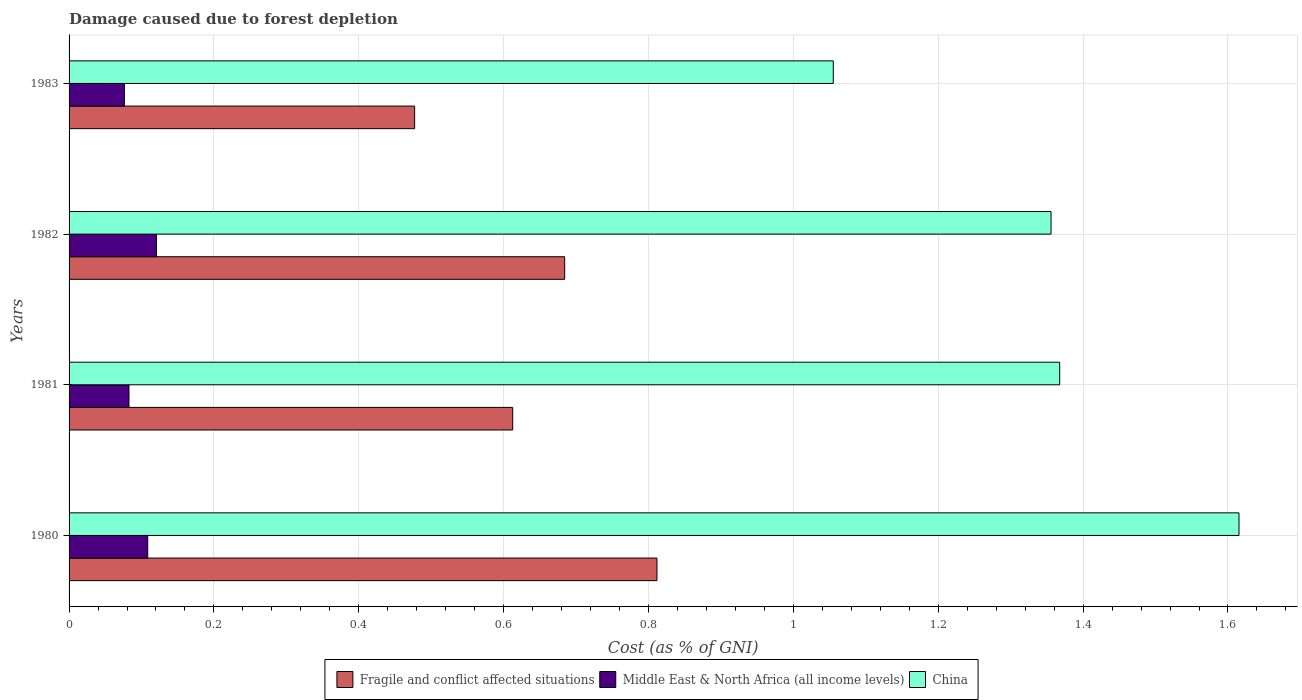How many different coloured bars are there?
Your answer should be very brief. 3. Are the number of bars per tick equal to the number of legend labels?
Offer a terse response. Yes. Are the number of bars on each tick of the Y-axis equal?
Your answer should be very brief. Yes. How many bars are there on the 1st tick from the bottom?
Your answer should be very brief. 3. What is the label of the 2nd group of bars from the top?
Keep it short and to the point. 1982. In how many cases, is the number of bars for a given year not equal to the number of legend labels?
Offer a terse response. 0. What is the cost of damage caused due to forest depletion in China in 1981?
Make the answer very short. 1.37. Across all years, what is the maximum cost of damage caused due to forest depletion in China?
Your answer should be very brief. 1.62. Across all years, what is the minimum cost of damage caused due to forest depletion in Fragile and conflict affected situations?
Make the answer very short. 0.48. What is the total cost of damage caused due to forest depletion in Fragile and conflict affected situations in the graph?
Ensure brevity in your answer.  2.59. What is the difference between the cost of damage caused due to forest depletion in China in 1981 and that in 1983?
Make the answer very short. 0.31. What is the difference between the cost of damage caused due to forest depletion in Fragile and conflict affected situations in 1983 and the cost of damage caused due to forest depletion in China in 1982?
Keep it short and to the point. -0.88. What is the average cost of damage caused due to forest depletion in Middle East & North Africa (all income levels) per year?
Offer a very short reply. 0.1. In the year 1981, what is the difference between the cost of damage caused due to forest depletion in Middle East & North Africa (all income levels) and cost of damage caused due to forest depletion in China?
Your response must be concise. -1.28. What is the ratio of the cost of damage caused due to forest depletion in Fragile and conflict affected situations in 1980 to that in 1981?
Keep it short and to the point. 1.33. What is the difference between the highest and the second highest cost of damage caused due to forest depletion in Fragile and conflict affected situations?
Ensure brevity in your answer.  0.13. What is the difference between the highest and the lowest cost of damage caused due to forest depletion in Middle East & North Africa (all income levels)?
Provide a succinct answer. 0.04. Is the sum of the cost of damage caused due to forest depletion in Fragile and conflict affected situations in 1980 and 1982 greater than the maximum cost of damage caused due to forest depletion in Middle East & North Africa (all income levels) across all years?
Your answer should be very brief. Yes. What does the 3rd bar from the top in 1983 represents?
Your answer should be compact. Fragile and conflict affected situations. What does the 1st bar from the bottom in 1980 represents?
Offer a terse response. Fragile and conflict affected situations. Is it the case that in every year, the sum of the cost of damage caused due to forest depletion in Fragile and conflict affected situations and cost of damage caused due to forest depletion in China is greater than the cost of damage caused due to forest depletion in Middle East & North Africa (all income levels)?
Offer a terse response. Yes. How many bars are there?
Provide a succinct answer. 12. Are all the bars in the graph horizontal?
Your response must be concise. Yes. How many years are there in the graph?
Make the answer very short. 4. What is the difference between two consecutive major ticks on the X-axis?
Provide a short and direct response. 0.2. Are the values on the major ticks of X-axis written in scientific E-notation?
Ensure brevity in your answer.  No. Where does the legend appear in the graph?
Make the answer very short. Bottom center. How many legend labels are there?
Make the answer very short. 3. How are the legend labels stacked?
Offer a terse response. Horizontal. What is the title of the graph?
Provide a succinct answer. Damage caused due to forest depletion. Does "Libya" appear as one of the legend labels in the graph?
Offer a very short reply. No. What is the label or title of the X-axis?
Offer a very short reply. Cost (as % of GNI). What is the label or title of the Y-axis?
Give a very brief answer. Years. What is the Cost (as % of GNI) in Fragile and conflict affected situations in 1980?
Your answer should be compact. 0.81. What is the Cost (as % of GNI) in Middle East & North Africa (all income levels) in 1980?
Your response must be concise. 0.11. What is the Cost (as % of GNI) of China in 1980?
Ensure brevity in your answer.  1.62. What is the Cost (as % of GNI) in Fragile and conflict affected situations in 1981?
Your response must be concise. 0.61. What is the Cost (as % of GNI) in Middle East & North Africa (all income levels) in 1981?
Offer a terse response. 0.08. What is the Cost (as % of GNI) of China in 1981?
Your response must be concise. 1.37. What is the Cost (as % of GNI) in Fragile and conflict affected situations in 1982?
Offer a terse response. 0.68. What is the Cost (as % of GNI) in Middle East & North Africa (all income levels) in 1982?
Provide a succinct answer. 0.12. What is the Cost (as % of GNI) in China in 1982?
Keep it short and to the point. 1.36. What is the Cost (as % of GNI) in Fragile and conflict affected situations in 1983?
Your answer should be compact. 0.48. What is the Cost (as % of GNI) of Middle East & North Africa (all income levels) in 1983?
Ensure brevity in your answer.  0.08. What is the Cost (as % of GNI) of China in 1983?
Give a very brief answer. 1.06. Across all years, what is the maximum Cost (as % of GNI) in Fragile and conflict affected situations?
Ensure brevity in your answer.  0.81. Across all years, what is the maximum Cost (as % of GNI) in Middle East & North Africa (all income levels)?
Give a very brief answer. 0.12. Across all years, what is the maximum Cost (as % of GNI) in China?
Your answer should be very brief. 1.62. Across all years, what is the minimum Cost (as % of GNI) in Fragile and conflict affected situations?
Ensure brevity in your answer.  0.48. Across all years, what is the minimum Cost (as % of GNI) in Middle East & North Africa (all income levels)?
Provide a succinct answer. 0.08. Across all years, what is the minimum Cost (as % of GNI) of China?
Make the answer very short. 1.06. What is the total Cost (as % of GNI) in Fragile and conflict affected situations in the graph?
Provide a succinct answer. 2.59. What is the total Cost (as % of GNI) in Middle East & North Africa (all income levels) in the graph?
Ensure brevity in your answer.  0.39. What is the total Cost (as % of GNI) of China in the graph?
Offer a terse response. 5.39. What is the difference between the Cost (as % of GNI) in Fragile and conflict affected situations in 1980 and that in 1981?
Offer a terse response. 0.2. What is the difference between the Cost (as % of GNI) in Middle East & North Africa (all income levels) in 1980 and that in 1981?
Offer a terse response. 0.03. What is the difference between the Cost (as % of GNI) of China in 1980 and that in 1981?
Offer a terse response. 0.25. What is the difference between the Cost (as % of GNI) in Fragile and conflict affected situations in 1980 and that in 1982?
Offer a very short reply. 0.13. What is the difference between the Cost (as % of GNI) in Middle East & North Africa (all income levels) in 1980 and that in 1982?
Make the answer very short. -0.01. What is the difference between the Cost (as % of GNI) of China in 1980 and that in 1982?
Offer a terse response. 0.26. What is the difference between the Cost (as % of GNI) in Fragile and conflict affected situations in 1980 and that in 1983?
Your response must be concise. 0.33. What is the difference between the Cost (as % of GNI) of Middle East & North Africa (all income levels) in 1980 and that in 1983?
Give a very brief answer. 0.03. What is the difference between the Cost (as % of GNI) of China in 1980 and that in 1983?
Ensure brevity in your answer.  0.56. What is the difference between the Cost (as % of GNI) of Fragile and conflict affected situations in 1981 and that in 1982?
Offer a terse response. -0.07. What is the difference between the Cost (as % of GNI) in Middle East & North Africa (all income levels) in 1981 and that in 1982?
Provide a succinct answer. -0.04. What is the difference between the Cost (as % of GNI) in China in 1981 and that in 1982?
Offer a very short reply. 0.01. What is the difference between the Cost (as % of GNI) of Fragile and conflict affected situations in 1981 and that in 1983?
Your answer should be very brief. 0.14. What is the difference between the Cost (as % of GNI) in Middle East & North Africa (all income levels) in 1981 and that in 1983?
Make the answer very short. 0.01. What is the difference between the Cost (as % of GNI) of China in 1981 and that in 1983?
Make the answer very short. 0.31. What is the difference between the Cost (as % of GNI) in Fragile and conflict affected situations in 1982 and that in 1983?
Keep it short and to the point. 0.21. What is the difference between the Cost (as % of GNI) of Middle East & North Africa (all income levels) in 1982 and that in 1983?
Your answer should be very brief. 0.04. What is the difference between the Cost (as % of GNI) of China in 1982 and that in 1983?
Give a very brief answer. 0.3. What is the difference between the Cost (as % of GNI) of Fragile and conflict affected situations in 1980 and the Cost (as % of GNI) of Middle East & North Africa (all income levels) in 1981?
Give a very brief answer. 0.73. What is the difference between the Cost (as % of GNI) of Fragile and conflict affected situations in 1980 and the Cost (as % of GNI) of China in 1981?
Offer a very short reply. -0.56. What is the difference between the Cost (as % of GNI) of Middle East & North Africa (all income levels) in 1980 and the Cost (as % of GNI) of China in 1981?
Offer a very short reply. -1.26. What is the difference between the Cost (as % of GNI) in Fragile and conflict affected situations in 1980 and the Cost (as % of GNI) in Middle East & North Africa (all income levels) in 1982?
Give a very brief answer. 0.69. What is the difference between the Cost (as % of GNI) of Fragile and conflict affected situations in 1980 and the Cost (as % of GNI) of China in 1982?
Your response must be concise. -0.54. What is the difference between the Cost (as % of GNI) of Middle East & North Africa (all income levels) in 1980 and the Cost (as % of GNI) of China in 1982?
Provide a short and direct response. -1.25. What is the difference between the Cost (as % of GNI) of Fragile and conflict affected situations in 1980 and the Cost (as % of GNI) of Middle East & North Africa (all income levels) in 1983?
Your response must be concise. 0.74. What is the difference between the Cost (as % of GNI) in Fragile and conflict affected situations in 1980 and the Cost (as % of GNI) in China in 1983?
Your answer should be very brief. -0.24. What is the difference between the Cost (as % of GNI) in Middle East & North Africa (all income levels) in 1980 and the Cost (as % of GNI) in China in 1983?
Your answer should be very brief. -0.95. What is the difference between the Cost (as % of GNI) of Fragile and conflict affected situations in 1981 and the Cost (as % of GNI) of Middle East & North Africa (all income levels) in 1982?
Offer a very short reply. 0.49. What is the difference between the Cost (as % of GNI) of Fragile and conflict affected situations in 1981 and the Cost (as % of GNI) of China in 1982?
Provide a short and direct response. -0.74. What is the difference between the Cost (as % of GNI) in Middle East & North Africa (all income levels) in 1981 and the Cost (as % of GNI) in China in 1982?
Make the answer very short. -1.27. What is the difference between the Cost (as % of GNI) in Fragile and conflict affected situations in 1981 and the Cost (as % of GNI) in Middle East & North Africa (all income levels) in 1983?
Give a very brief answer. 0.54. What is the difference between the Cost (as % of GNI) in Fragile and conflict affected situations in 1981 and the Cost (as % of GNI) in China in 1983?
Your answer should be very brief. -0.44. What is the difference between the Cost (as % of GNI) of Middle East & North Africa (all income levels) in 1981 and the Cost (as % of GNI) of China in 1983?
Ensure brevity in your answer.  -0.97. What is the difference between the Cost (as % of GNI) of Fragile and conflict affected situations in 1982 and the Cost (as % of GNI) of Middle East & North Africa (all income levels) in 1983?
Make the answer very short. 0.61. What is the difference between the Cost (as % of GNI) of Fragile and conflict affected situations in 1982 and the Cost (as % of GNI) of China in 1983?
Ensure brevity in your answer.  -0.37. What is the difference between the Cost (as % of GNI) in Middle East & North Africa (all income levels) in 1982 and the Cost (as % of GNI) in China in 1983?
Make the answer very short. -0.93. What is the average Cost (as % of GNI) in Fragile and conflict affected situations per year?
Offer a very short reply. 0.65. What is the average Cost (as % of GNI) of Middle East & North Africa (all income levels) per year?
Provide a short and direct response. 0.1. What is the average Cost (as % of GNI) of China per year?
Provide a succinct answer. 1.35. In the year 1980, what is the difference between the Cost (as % of GNI) in Fragile and conflict affected situations and Cost (as % of GNI) in Middle East & North Africa (all income levels)?
Ensure brevity in your answer.  0.7. In the year 1980, what is the difference between the Cost (as % of GNI) in Fragile and conflict affected situations and Cost (as % of GNI) in China?
Your answer should be very brief. -0.8. In the year 1980, what is the difference between the Cost (as % of GNI) of Middle East & North Africa (all income levels) and Cost (as % of GNI) of China?
Your response must be concise. -1.51. In the year 1981, what is the difference between the Cost (as % of GNI) in Fragile and conflict affected situations and Cost (as % of GNI) in Middle East & North Africa (all income levels)?
Make the answer very short. 0.53. In the year 1981, what is the difference between the Cost (as % of GNI) of Fragile and conflict affected situations and Cost (as % of GNI) of China?
Offer a terse response. -0.76. In the year 1981, what is the difference between the Cost (as % of GNI) in Middle East & North Africa (all income levels) and Cost (as % of GNI) in China?
Your response must be concise. -1.28. In the year 1982, what is the difference between the Cost (as % of GNI) in Fragile and conflict affected situations and Cost (as % of GNI) in Middle East & North Africa (all income levels)?
Offer a terse response. 0.56. In the year 1982, what is the difference between the Cost (as % of GNI) of Fragile and conflict affected situations and Cost (as % of GNI) of China?
Give a very brief answer. -0.67. In the year 1982, what is the difference between the Cost (as % of GNI) of Middle East & North Africa (all income levels) and Cost (as % of GNI) of China?
Your response must be concise. -1.23. In the year 1983, what is the difference between the Cost (as % of GNI) in Fragile and conflict affected situations and Cost (as % of GNI) in Middle East & North Africa (all income levels)?
Your answer should be very brief. 0.4. In the year 1983, what is the difference between the Cost (as % of GNI) in Fragile and conflict affected situations and Cost (as % of GNI) in China?
Your answer should be compact. -0.58. In the year 1983, what is the difference between the Cost (as % of GNI) in Middle East & North Africa (all income levels) and Cost (as % of GNI) in China?
Give a very brief answer. -0.98. What is the ratio of the Cost (as % of GNI) of Fragile and conflict affected situations in 1980 to that in 1981?
Your answer should be compact. 1.33. What is the ratio of the Cost (as % of GNI) of Middle East & North Africa (all income levels) in 1980 to that in 1981?
Give a very brief answer. 1.31. What is the ratio of the Cost (as % of GNI) in China in 1980 to that in 1981?
Ensure brevity in your answer.  1.18. What is the ratio of the Cost (as % of GNI) in Fragile and conflict affected situations in 1980 to that in 1982?
Keep it short and to the point. 1.19. What is the ratio of the Cost (as % of GNI) in Middle East & North Africa (all income levels) in 1980 to that in 1982?
Give a very brief answer. 0.9. What is the ratio of the Cost (as % of GNI) of China in 1980 to that in 1982?
Offer a very short reply. 1.19. What is the ratio of the Cost (as % of GNI) in Fragile and conflict affected situations in 1980 to that in 1983?
Provide a short and direct response. 1.7. What is the ratio of the Cost (as % of GNI) in Middle East & North Africa (all income levels) in 1980 to that in 1983?
Give a very brief answer. 1.42. What is the ratio of the Cost (as % of GNI) of China in 1980 to that in 1983?
Ensure brevity in your answer.  1.53. What is the ratio of the Cost (as % of GNI) in Fragile and conflict affected situations in 1981 to that in 1982?
Make the answer very short. 0.9. What is the ratio of the Cost (as % of GNI) of Middle East & North Africa (all income levels) in 1981 to that in 1982?
Offer a very short reply. 0.68. What is the ratio of the Cost (as % of GNI) of China in 1981 to that in 1982?
Your answer should be very brief. 1.01. What is the ratio of the Cost (as % of GNI) of Fragile and conflict affected situations in 1981 to that in 1983?
Make the answer very short. 1.28. What is the ratio of the Cost (as % of GNI) in Middle East & North Africa (all income levels) in 1981 to that in 1983?
Give a very brief answer. 1.08. What is the ratio of the Cost (as % of GNI) of China in 1981 to that in 1983?
Keep it short and to the point. 1.3. What is the ratio of the Cost (as % of GNI) in Fragile and conflict affected situations in 1982 to that in 1983?
Ensure brevity in your answer.  1.43. What is the ratio of the Cost (as % of GNI) of Middle East & North Africa (all income levels) in 1982 to that in 1983?
Offer a very short reply. 1.58. What is the ratio of the Cost (as % of GNI) in China in 1982 to that in 1983?
Provide a short and direct response. 1.28. What is the difference between the highest and the second highest Cost (as % of GNI) of Fragile and conflict affected situations?
Ensure brevity in your answer.  0.13. What is the difference between the highest and the second highest Cost (as % of GNI) of Middle East & North Africa (all income levels)?
Provide a short and direct response. 0.01. What is the difference between the highest and the second highest Cost (as % of GNI) of China?
Your answer should be compact. 0.25. What is the difference between the highest and the lowest Cost (as % of GNI) in Fragile and conflict affected situations?
Ensure brevity in your answer.  0.33. What is the difference between the highest and the lowest Cost (as % of GNI) in Middle East & North Africa (all income levels)?
Give a very brief answer. 0.04. What is the difference between the highest and the lowest Cost (as % of GNI) in China?
Your response must be concise. 0.56. 